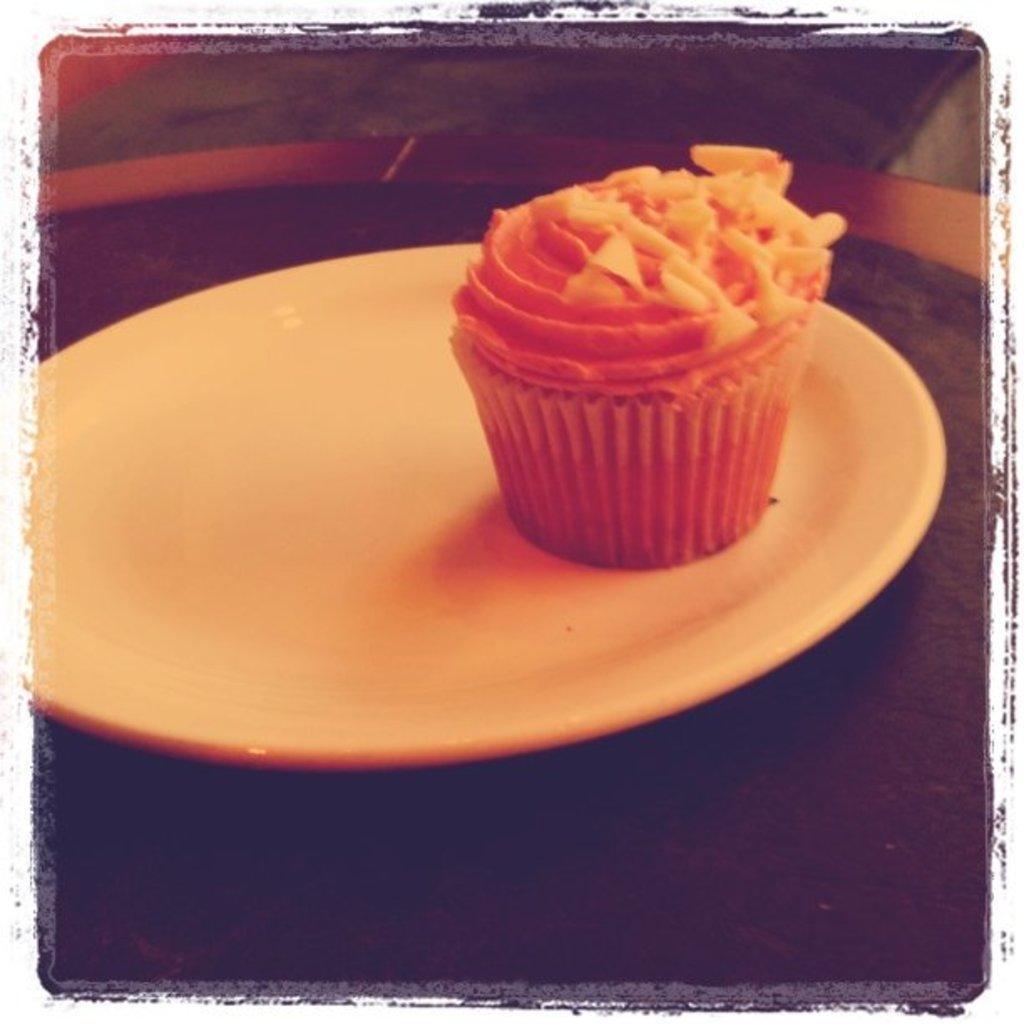Could you give a brief overview of what you see in this image? This image consists of a muffin kept on a plate. The plate is in white color. 